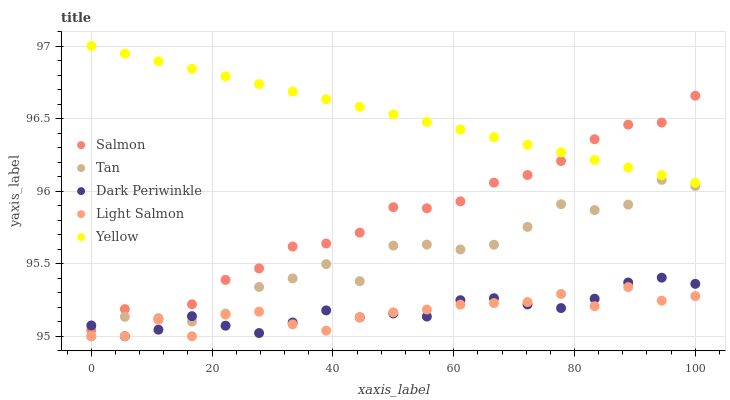Does Light Salmon have the minimum area under the curve?
Answer yes or no. Yes. Does Yellow have the maximum area under the curve?
Answer yes or no. Yes. Does Salmon have the minimum area under the curve?
Answer yes or no. No. Does Salmon have the maximum area under the curve?
Answer yes or no. No. Is Yellow the smoothest?
Answer yes or no. Yes. Is Tan the roughest?
Answer yes or no. Yes. Is Salmon the smoothest?
Answer yes or no. No. Is Salmon the roughest?
Answer yes or no. No. Does Tan have the lowest value?
Answer yes or no. Yes. Does Salmon have the lowest value?
Answer yes or no. No. Does Yellow have the highest value?
Answer yes or no. Yes. Does Salmon have the highest value?
Answer yes or no. No. Is Light Salmon less than Yellow?
Answer yes or no. Yes. Is Salmon greater than Tan?
Answer yes or no. Yes. Does Light Salmon intersect Tan?
Answer yes or no. Yes. Is Light Salmon less than Tan?
Answer yes or no. No. Is Light Salmon greater than Tan?
Answer yes or no. No. Does Light Salmon intersect Yellow?
Answer yes or no. No. 